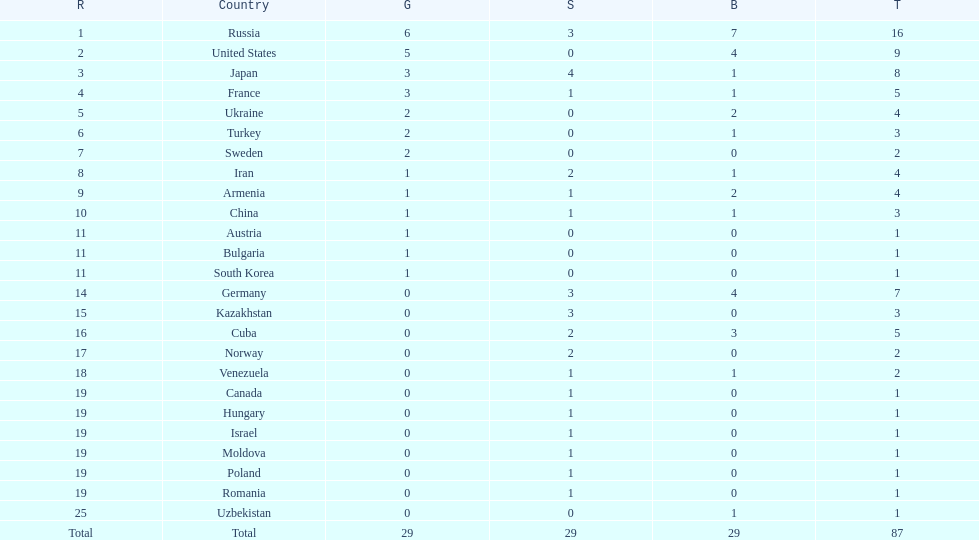Who won more gold medals than the united states? Russia. 